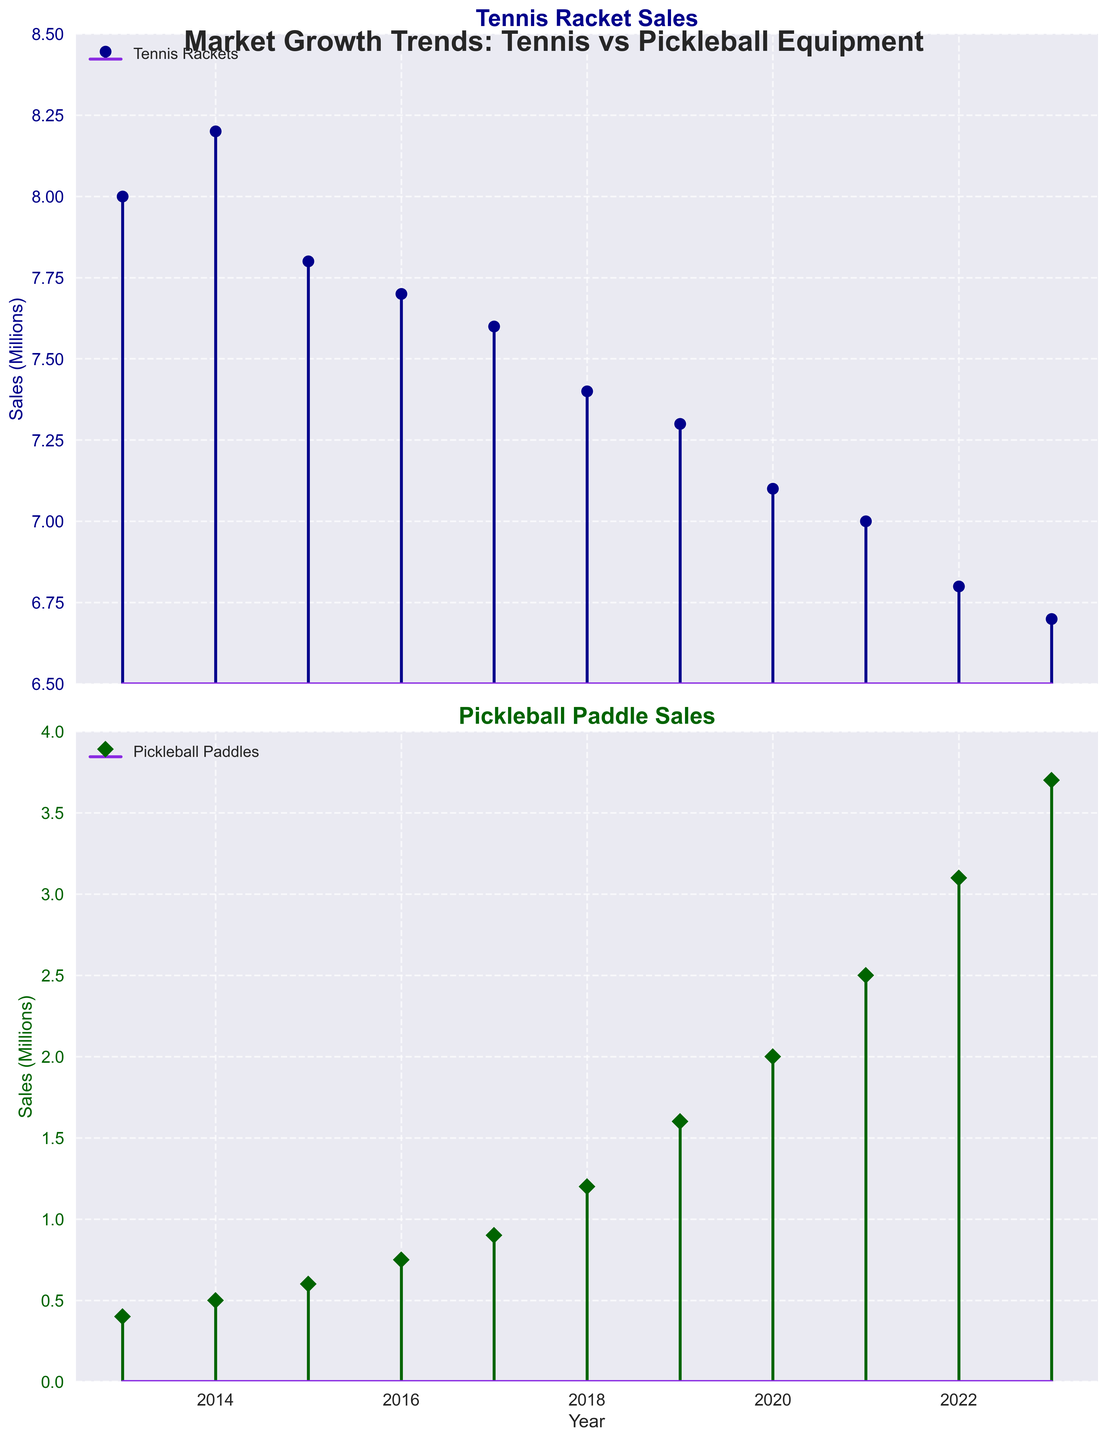What are the sales figures for tennis rackets and pickleball paddles in 2013? The first subplot shows the sales figures for tennis rackets, and the second subplot shows the sales figures for pickleball paddles. In 2013, the tennis racket sales are 8 million, and the pickleball paddle sales are 0.4 million.
Answer: Tennis: 8 million, Pickleball: 0.4 million How do the sales of pickleball paddles change from 2013 to 2023? The second subplot shows the increasing trend of pickleball paddle sales. In 2013, the sales were 0.4 million, and in 2023, they reached 3.7 million. The change can be seen as a continuous increase over the years.
Answer: Increased from 0.4 million to 3.7 million Which year shows the highest sales for pickleball paddles? The highest point in the second subplot indicates the highest sales year for pickleball paddles. The year 2023 shows the highest sales with 3.7 million.
Answer: 2023 What is the overall trend in tennis racket sales over the decade? The first subplot shows the trend of tennis racket sales from 2013 to 2023. The sales start at 8 million in 2013 and decrease to 6.7 million in 2023, indicating an overall declining trend.
Answer: Declining trend By how much did pickleball paddle sales increase from 2018 to 2020? From the second subplot, pickleball paddle sales in 2018 are 1.2 million and in 2020 are 2 million. The increase is calculated as 2 million - 1.2 million = 0.8 million.
Answer: 0.8 million Compare the sales of tennis rackets and pickleball paddles in 2016. Which is higher, and by how much? In the first subplot, tennis racket sales in 2016 are 7.7 million. In the second subplot, pickleball paddle sales in 2016 are 0.75 million. The difference is 7.7 million - 0.75 million = 6.95 million. Tennis racket sales are higher by 6.95 million.
Answer: Tennis rackets are higher by 6.95 million What is the percentage increase in pickleball paddle sales from 2013 to 2023? Pickleball paddle sales in 2013 are 0.4 million and in 2023 are 3.7 million. The percentage increase is calculated as ((3.7 - 0.4) / 0.4) * 100 = 825%.
Answer: 825% How did the sales of tennis rackets change between 2020 and 2021? The first subplot shows sales decreasing from 7.1 million in 2020 to 7 million in 2021. The decrease is 0.1 million.
Answer: Decreased by 0.1 million What's the average annual sales of tennis rackets from 2013 to 2023? The sales figures for tennis rackets from 2013 to 2023 are 8, 8.2, 7.8, 7.7, 7.6, 7.4, 7.3, 7.1, 7, 6.8, and 6.7 million respectively. The sum is 83.6 million over 11 years, so the average is 83.6 / 11 ≈ 7.6 million.
Answer: 7.6 million 